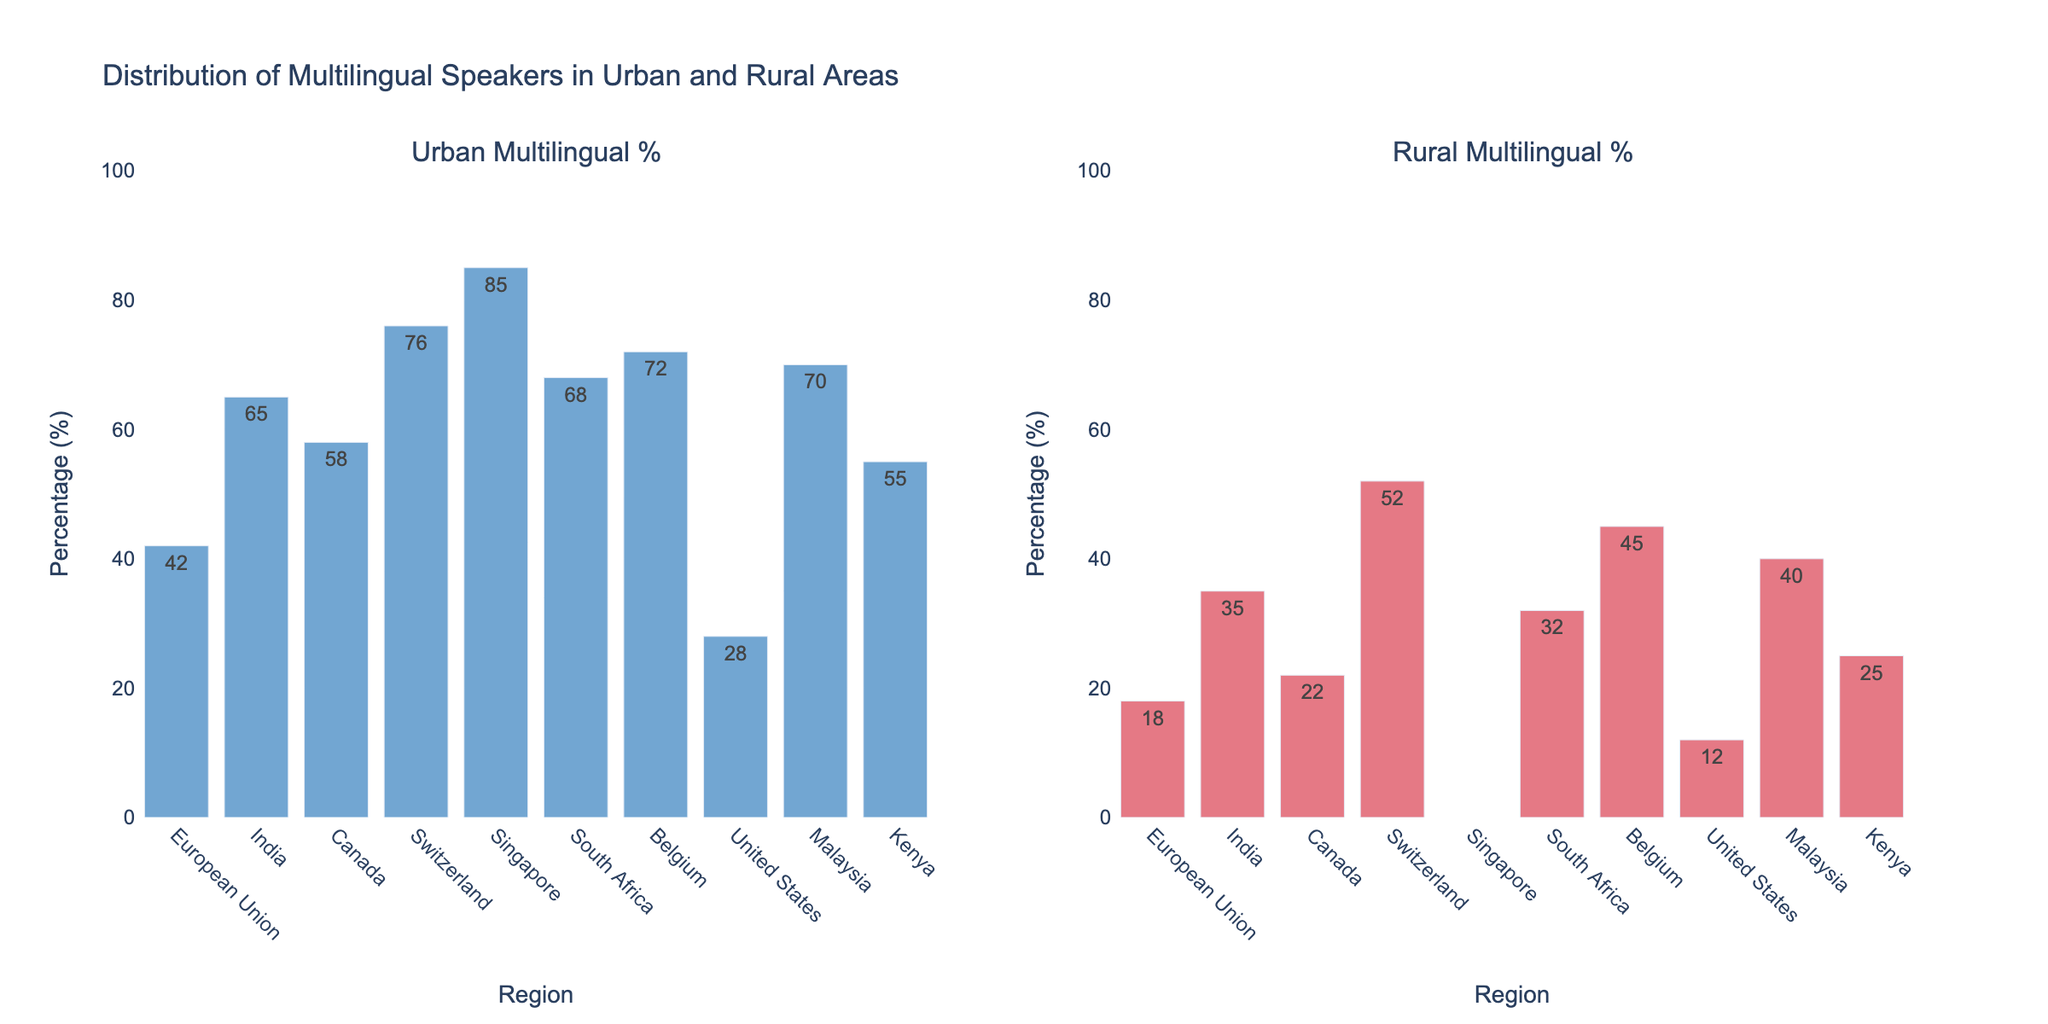What is the title of the figure? The title of the figure is clearly labeled at the top and provides an overall description of what the figure is about.
Answer: Distribution of Multilingual Speakers in Urban and Rural Areas Which region has the highest percentage of multilingual speakers in urban areas? By examining the bar heights in the urban subplot, we can see that Singapore has the tallest bar.
Answer: Singapore How many urban regions have a multilingual percentage of over 50%? To answer this, we count the number of bars in the urban subplot with values above 50%. The regions are India, Canada, Switzerland, Singapore, South Africa, Belgium, and Malaysia.
Answer: 7 What is the difference in the percentage of multilingual speakers between urban and rural areas in Belgium? We subtract the rural multilingual percentage from the urban multilingual percentage for Belgium: 72% - 45% = 27%.
Answer: 27% What is the average percentage of multilingual speakers in rural areas across the listed regions? We add up the percentages of multilingual speakers in rural areas for all regions (excluding Singapore, marked as N/A) and divide by the number of those regions: (18 + 35 + 22 + 52 + 32 + 45 + 12 + 40 + 25) / 9 = 31.23%.
Answer: 31.23% Which region shows the smallest difference between urban and rural multilingual percentages? Comparing the differences for each region, Switzerland has the smallest difference as 76% - 52% = 24%, and all other differences are higher.
Answer: Switzerland Which regions do not have data for rural multilingual percentages, and why might that be significant? By looking at the figure, Singapore is the region without a rural multilingual percentage marked as N/A, indicating that the data might not be available or not applicable.
Answer: Singapore How does the multilingual percentage in urban areas of the United States compare to that in rural areas? We compare the bar heights in the urban and rural subplots for the United States: Urban (28%), Rural (12%). The urban percentage is significantly higher.
Answer: Higher in Urban What region exhibits the largest gap between urban and rural multilingual speakers, and what is the difference? By calculating the differences, Singapore shows the largest gap, with an urban percentage of 85% and no data for rural areas, indicating a potential urban concentration.
Answer: Singapore What is the median percentage of multilingual speakers in urban areas across the listed regions? To find the median, organize the urban percentages in ascending order: 28, 42, 55, 58, 65, 68, 70, 72, 76, 85. The middle value, or median, is (65 + 68) / 2 = 66.5%.
Answer: 66.5% 